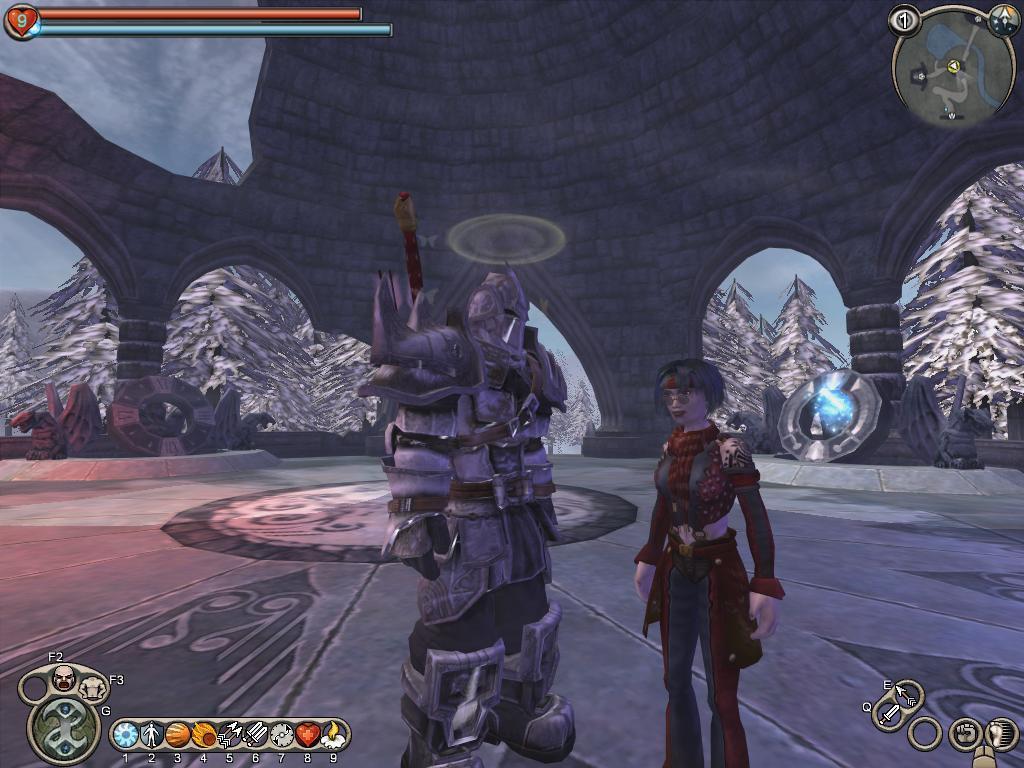How would you summarize this image in a sentence or two? This is an animated image. Here I can see two persons standing on the floor. In the background there is a wall and some trees. 